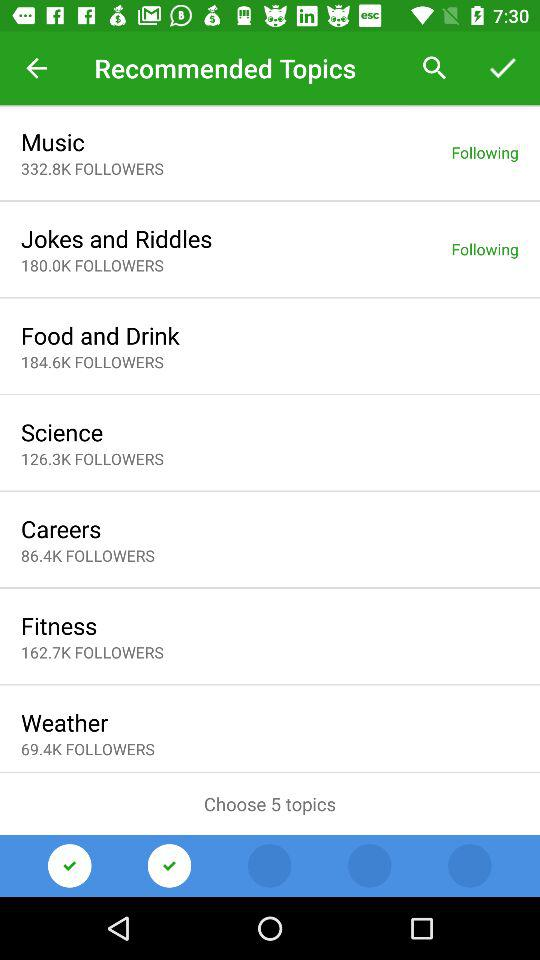What's the total number of music followers? The total number of music followers is 332.8K. 